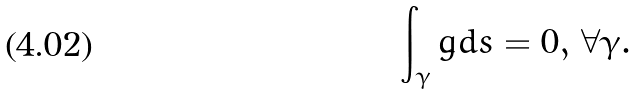<formula> <loc_0><loc_0><loc_500><loc_500>\int _ { \gamma } \dot { g } d s = 0 , \, \forall \gamma .</formula> 